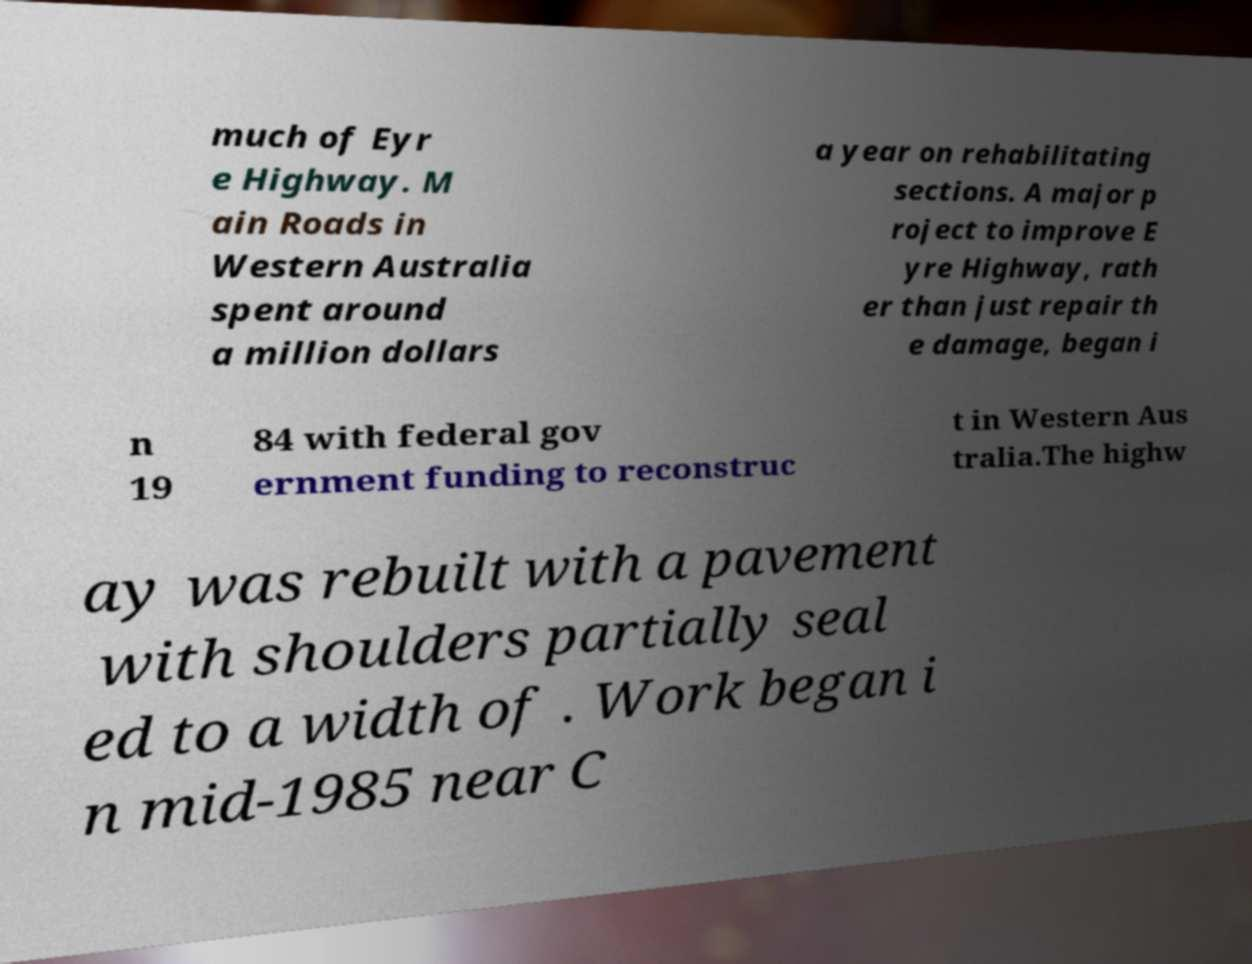Please read and relay the text visible in this image. What does it say? much of Eyr e Highway. M ain Roads in Western Australia spent around a million dollars a year on rehabilitating sections. A major p roject to improve E yre Highway, rath er than just repair th e damage, began i n 19 84 with federal gov ernment funding to reconstruc t in Western Aus tralia.The highw ay was rebuilt with a pavement with shoulders partially seal ed to a width of . Work began i n mid-1985 near C 